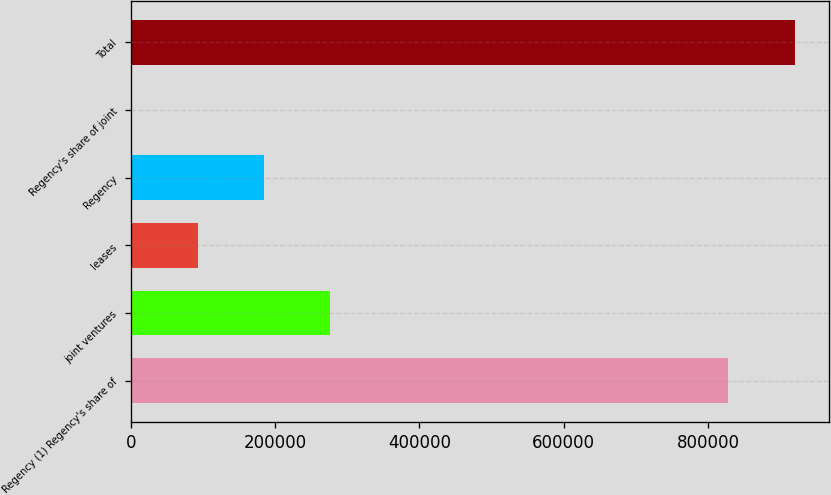<chart> <loc_0><loc_0><loc_500><loc_500><bar_chart><fcel>Regency (1) Regency's share of<fcel>joint ventures<fcel>leases<fcel>Regency<fcel>Regency's share of joint<fcel>Total<nl><fcel>827419<fcel>276599<fcel>92462.3<fcel>184531<fcel>394<fcel>921077<nl></chart> 